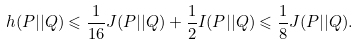Convert formula to latex. <formula><loc_0><loc_0><loc_500><loc_500>h ( P | | Q ) \leqslant \frac { 1 } { 1 6 } J ( P | | Q ) + \frac { 1 } { 2 } I ( P | | Q ) \leqslant \frac { 1 } { 8 } J ( P | | Q ) .</formula> 